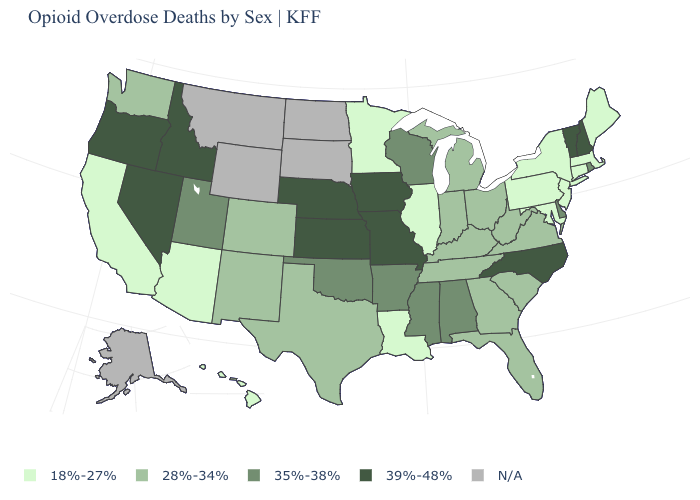Name the states that have a value in the range 18%-27%?
Keep it brief. Arizona, California, Connecticut, Hawaii, Illinois, Louisiana, Maine, Maryland, Massachusetts, Minnesota, New Jersey, New York, Pennsylvania. Name the states that have a value in the range 39%-48%?
Answer briefly. Idaho, Iowa, Kansas, Missouri, Nebraska, Nevada, New Hampshire, North Carolina, Oregon, Vermont. What is the value of Maryland?
Quick response, please. 18%-27%. Name the states that have a value in the range 18%-27%?
Give a very brief answer. Arizona, California, Connecticut, Hawaii, Illinois, Louisiana, Maine, Maryland, Massachusetts, Minnesota, New Jersey, New York, Pennsylvania. What is the lowest value in the USA?
Answer briefly. 18%-27%. Name the states that have a value in the range 28%-34%?
Give a very brief answer. Colorado, Florida, Georgia, Indiana, Kentucky, Michigan, New Mexico, Ohio, South Carolina, Tennessee, Texas, Virginia, Washington, West Virginia. Does the first symbol in the legend represent the smallest category?
Keep it brief. Yes. What is the value of Arizona?
Quick response, please. 18%-27%. How many symbols are there in the legend?
Be succinct. 5. What is the value of Tennessee?
Give a very brief answer. 28%-34%. Does Connecticut have the highest value in the Northeast?
Give a very brief answer. No. Does Mississippi have the lowest value in the USA?
Concise answer only. No. What is the value of Nevada?
Be succinct. 39%-48%. What is the value of Alabama?
Keep it brief. 35%-38%. Which states have the highest value in the USA?
Give a very brief answer. Idaho, Iowa, Kansas, Missouri, Nebraska, Nevada, New Hampshire, North Carolina, Oregon, Vermont. 